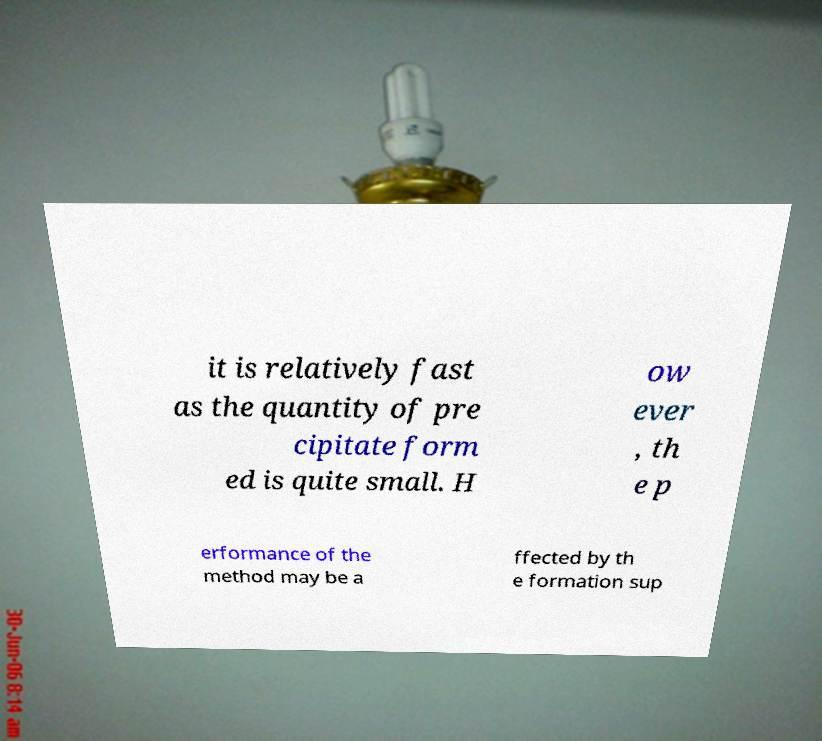For documentation purposes, I need the text within this image transcribed. Could you provide that? it is relatively fast as the quantity of pre cipitate form ed is quite small. H ow ever , th e p erformance of the method may be a ffected by th e formation sup 